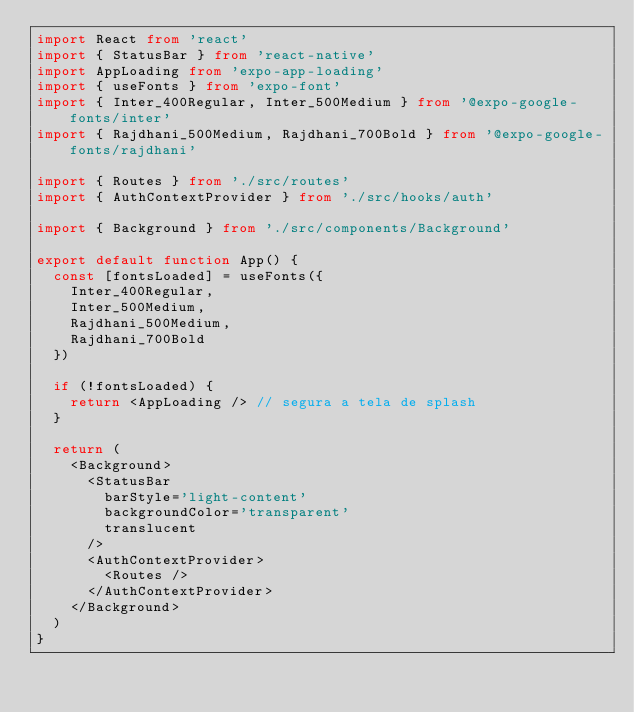Convert code to text. <code><loc_0><loc_0><loc_500><loc_500><_TypeScript_>import React from 'react'
import { StatusBar } from 'react-native'
import AppLoading from 'expo-app-loading'
import { useFonts } from 'expo-font'
import { Inter_400Regular, Inter_500Medium } from '@expo-google-fonts/inter'
import { Rajdhani_500Medium, Rajdhani_700Bold } from '@expo-google-fonts/rajdhani'

import { Routes } from './src/routes'
import { AuthContextProvider } from './src/hooks/auth'

import { Background } from './src/components/Background'

export default function App() {
  const [fontsLoaded] = useFonts({
    Inter_400Regular,
    Inter_500Medium,
    Rajdhani_500Medium,
    Rajdhani_700Bold
  })

  if (!fontsLoaded) {
    return <AppLoading /> // segura a tela de splash
  }

  return (
    <Background>
      <StatusBar 
        barStyle='light-content'
        backgroundColor='transparent'
        translucent
      />
      <AuthContextProvider>
        <Routes />
      </AuthContextProvider>
    </Background>
  )
}
</code> 